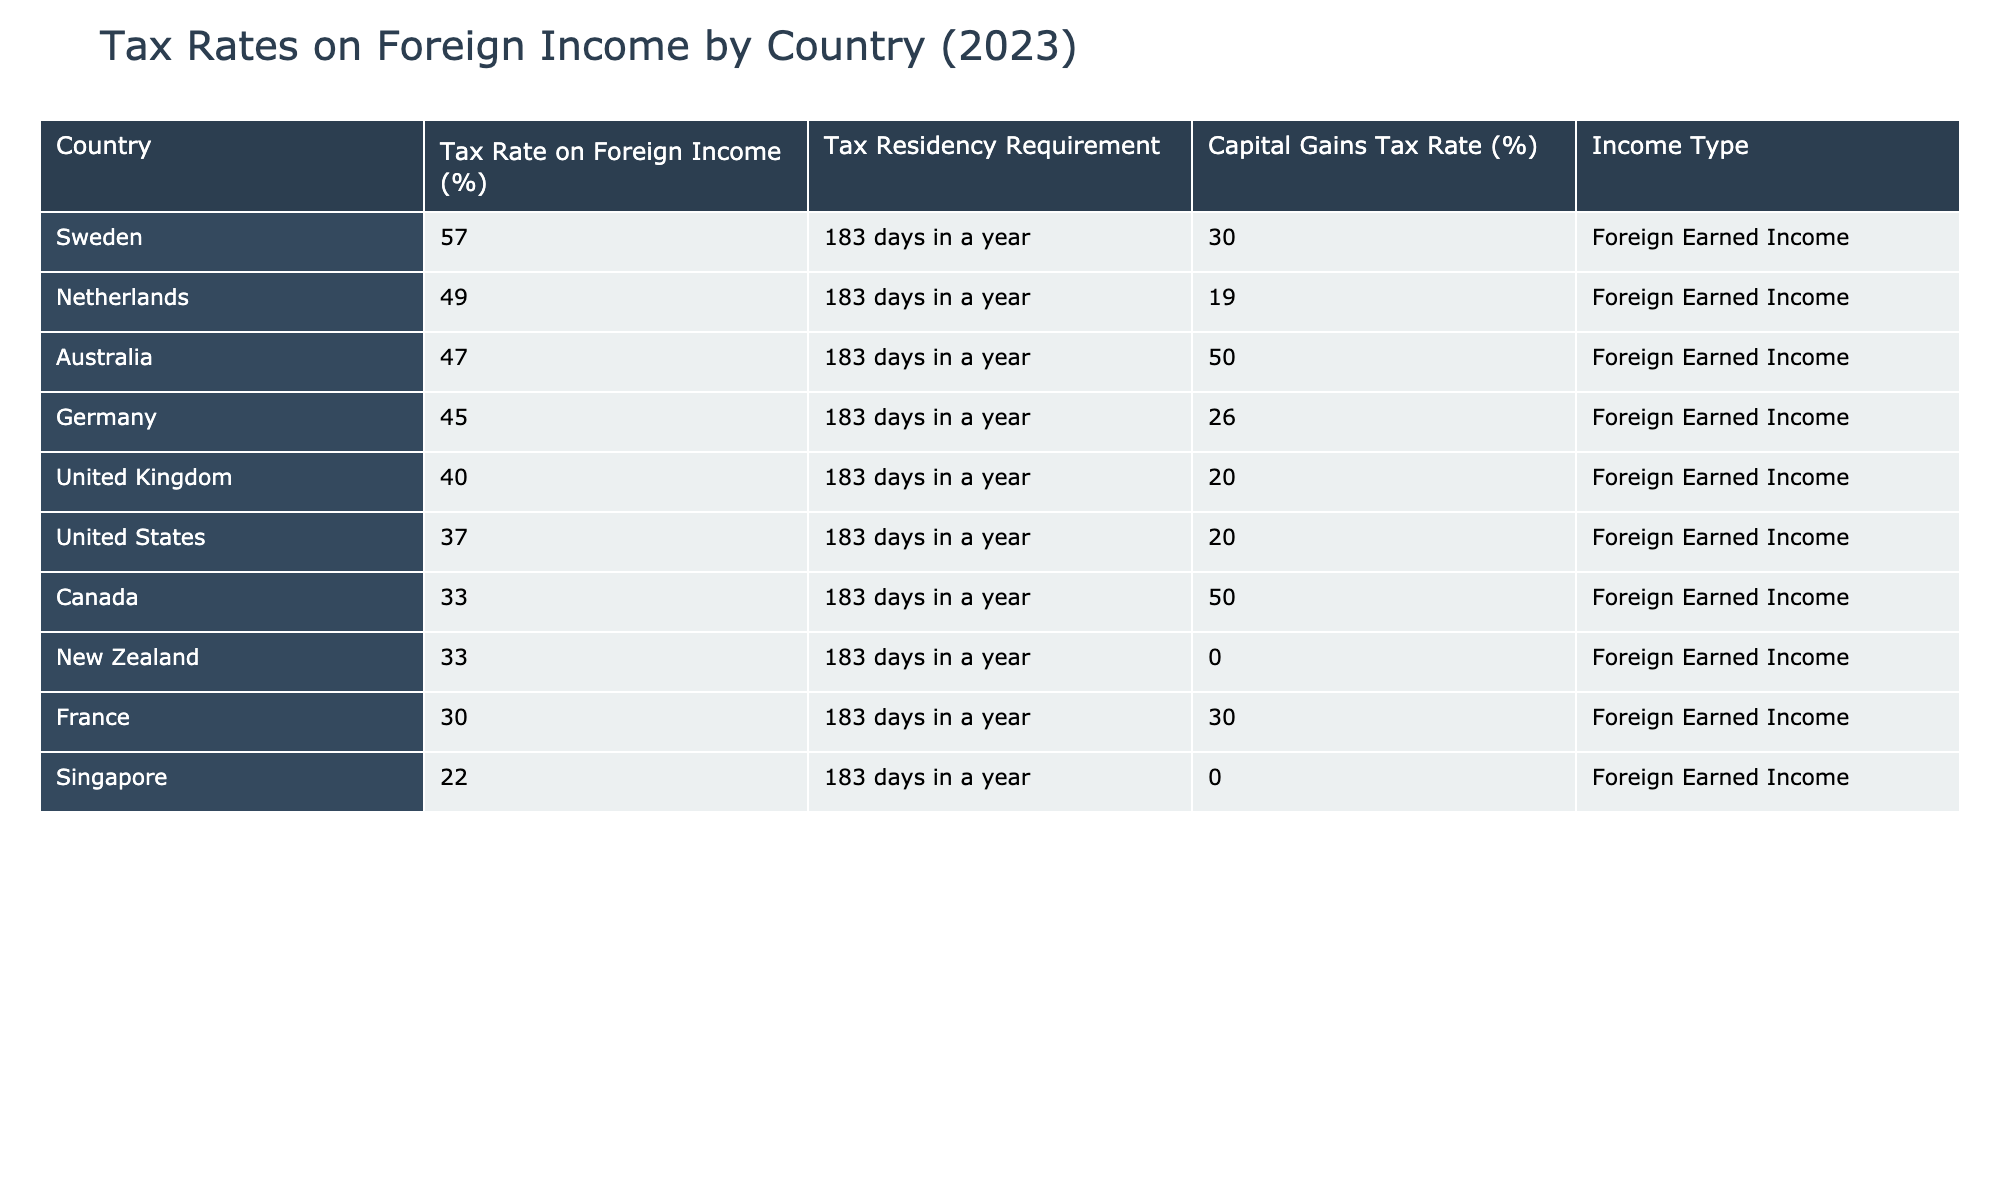What is the highest tax rate on foreign income listed in the table? The highest tax rate on foreign income can be found by looking at the "Tax Rate on Foreign Income (%)" column and identifying the maximum value. The highest value in this column is 57, which corresponds to Sweden.
Answer: 57 Which country has the lowest capital gains tax rate? To find the lowest capital gains tax rate, we check the "Capital Gains Tax Rate (%)" column and look for the minimum value. The lowest value is 0%, and it is applicable to New Zealand and Singapore.
Answer: 0 How many countries have a tax rate above 40%? We need to count the number of countries where the tax rate on foreign income is greater than 40%. Looking at the table, Australia, United Kingdom, Germany, Sweden, and Netherlands all have rates above 40%, totaling 5 countries.
Answer: 5 Is Canada's foreign income tax rate higher than France's? To answer this question, compare the values from the "Tax Rate on Foreign Income (%)" column for Canada (33%) and France (30%). Since 33% is greater than 30%, the statement is true.
Answer: Yes What is the average tax rate on foreign income for the countries listed? We first sum all the tax rates: 47 + 33 + 40 + 45 + 30 + 33 + 22 + 37 + 57 + 49 = 393. There are 10 data points (countries), so we divide the sum by 10: 393 / 10 = 39.3.
Answer: 39.3 Which country has a capital gains tax rate of 20%? Look through the "Capital Gains Tax Rate (%)" column for the value of 20%. This value corresponds to both the United States and United Kingdom.
Answer: United States and United Kingdom If I want to invest where the foreign income tax rate is lower than 35%, which countries should I consider? We check the "Tax Rate on Foreign Income (%)" column for values less than 35%. The qualifying countries are New Zealand (33%) and Singapore (22%).
Answer: New Zealand and Singapore How does the tax residency requirement differ for these countries, based on the table? The table shows that all listed countries require a tax residency of 183 days in a year for foreign income taxation. Thus, there is no difference in the residency requirement.
Answer: No difference 